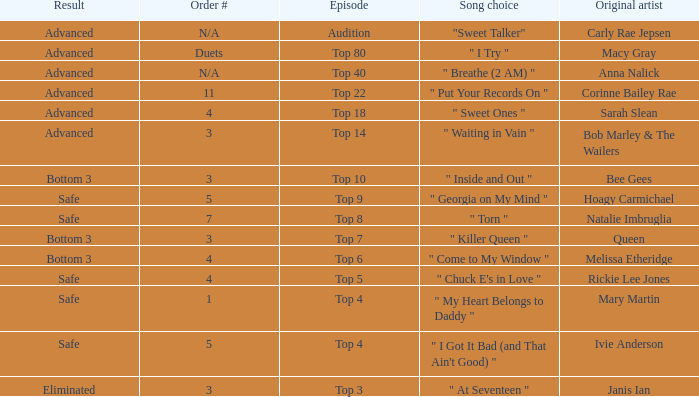Which one of the songs was originally performed by Rickie Lee Jones? " Chuck E's in Love ". 